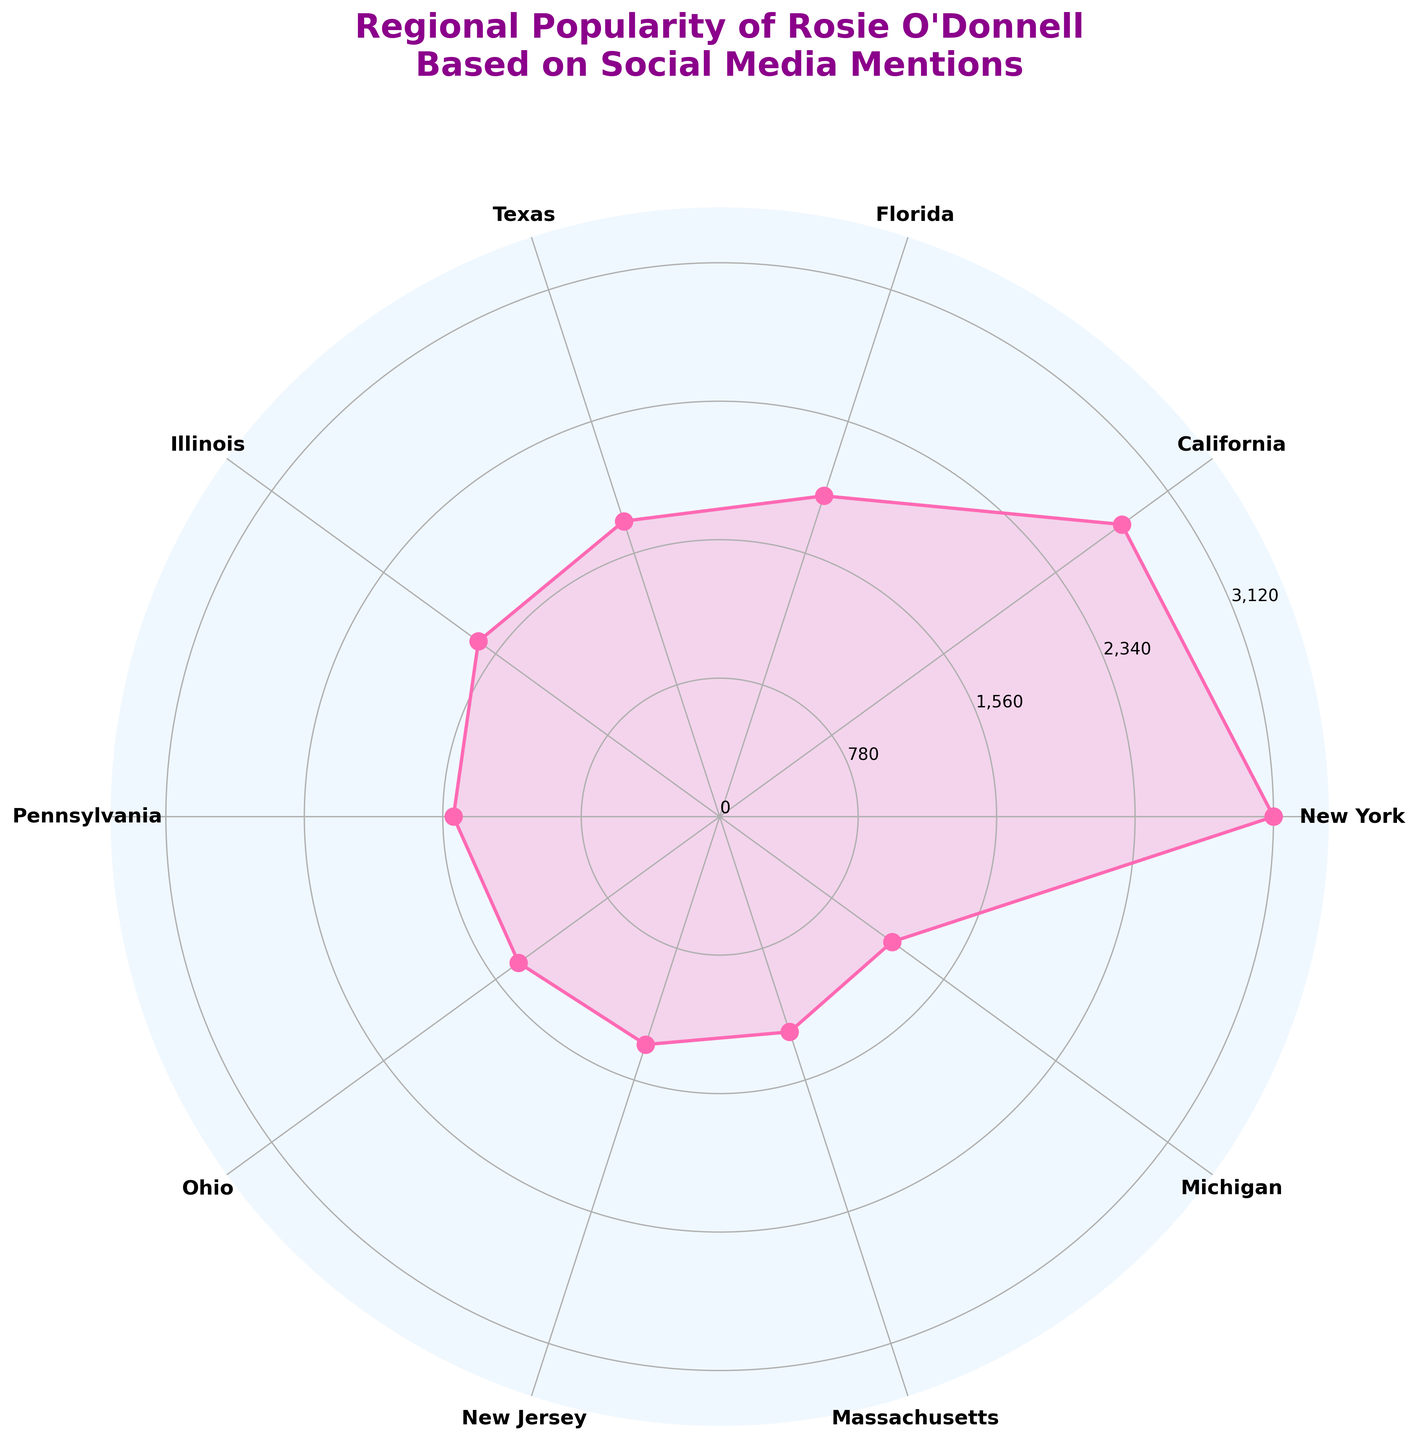What's the title of the figure? The title is located at the top of the figure. It reads, "Regional Popularity of Rosie O'Donnell Based on Social Media Mentions".
Answer: Regional Popularity of Rosie O'Donnell Based on Social Media Mentions Which region has the highest number of mentions? By looking at the plotted points and labels, the region with the highest mention count is at the tip of the highest spike, which corresponds to New York.
Answer: New York How many regions have mentions greater than 1,500? By examining the values along the axes, we can see that New York, California, Florida, Texas, and Illinois have mention counts greater than 1,500. This means there are exactly five regions above this threshold.
Answer: 5 What is the color used to plot the data points? Observing the lines and filled areas of the plot, the prominent color of the data points and the filled area is pink.
Answer: Pink What is the sum of mentions from Ohio and New Jersey? Locate the mentions for Ohio and New Jersey, which are 1400 and 1350 respectively. Adding these gives 1400 + 1350 = 2750.
Answer: 2750 Which region has the fewest mentions? The region with the fewest mentions is at the lowest point on the figure, which is Michigan with 1200 mentions.
Answer: Michigan How many regions have mentions less than 2,000? By examining the labels and values, mentions less than 2000 include Florida, Texas, Illinois, Pennsylvania, Ohio, New Jersey, Massachusetts, and Michigan. This totals to eight regions.
Answer: 8 What is the difference in mentions between California and Michigan? California has 2800 mentions, and Michigan has 1200 mentions. The difference is 2800 - 1200 = 1600.
Answer: 1600 Which region has slightly fewer mentions than Texas? Texas has 1750 mentions, and Illinois, with 1680 mentions, is the region slightly fewer than Texas in mention count.
Answer: Illinois What is the average number of mentions across all regions? Sum all the mentions: 3120 + 2800 + 1900 + 1750 + 1680 + 1500 + 1400 + 1350 + 1275 + 1200 = 17975. Divide by the number of regions: 17975 / 10 = 1797.5.
Answer: 1797.5 